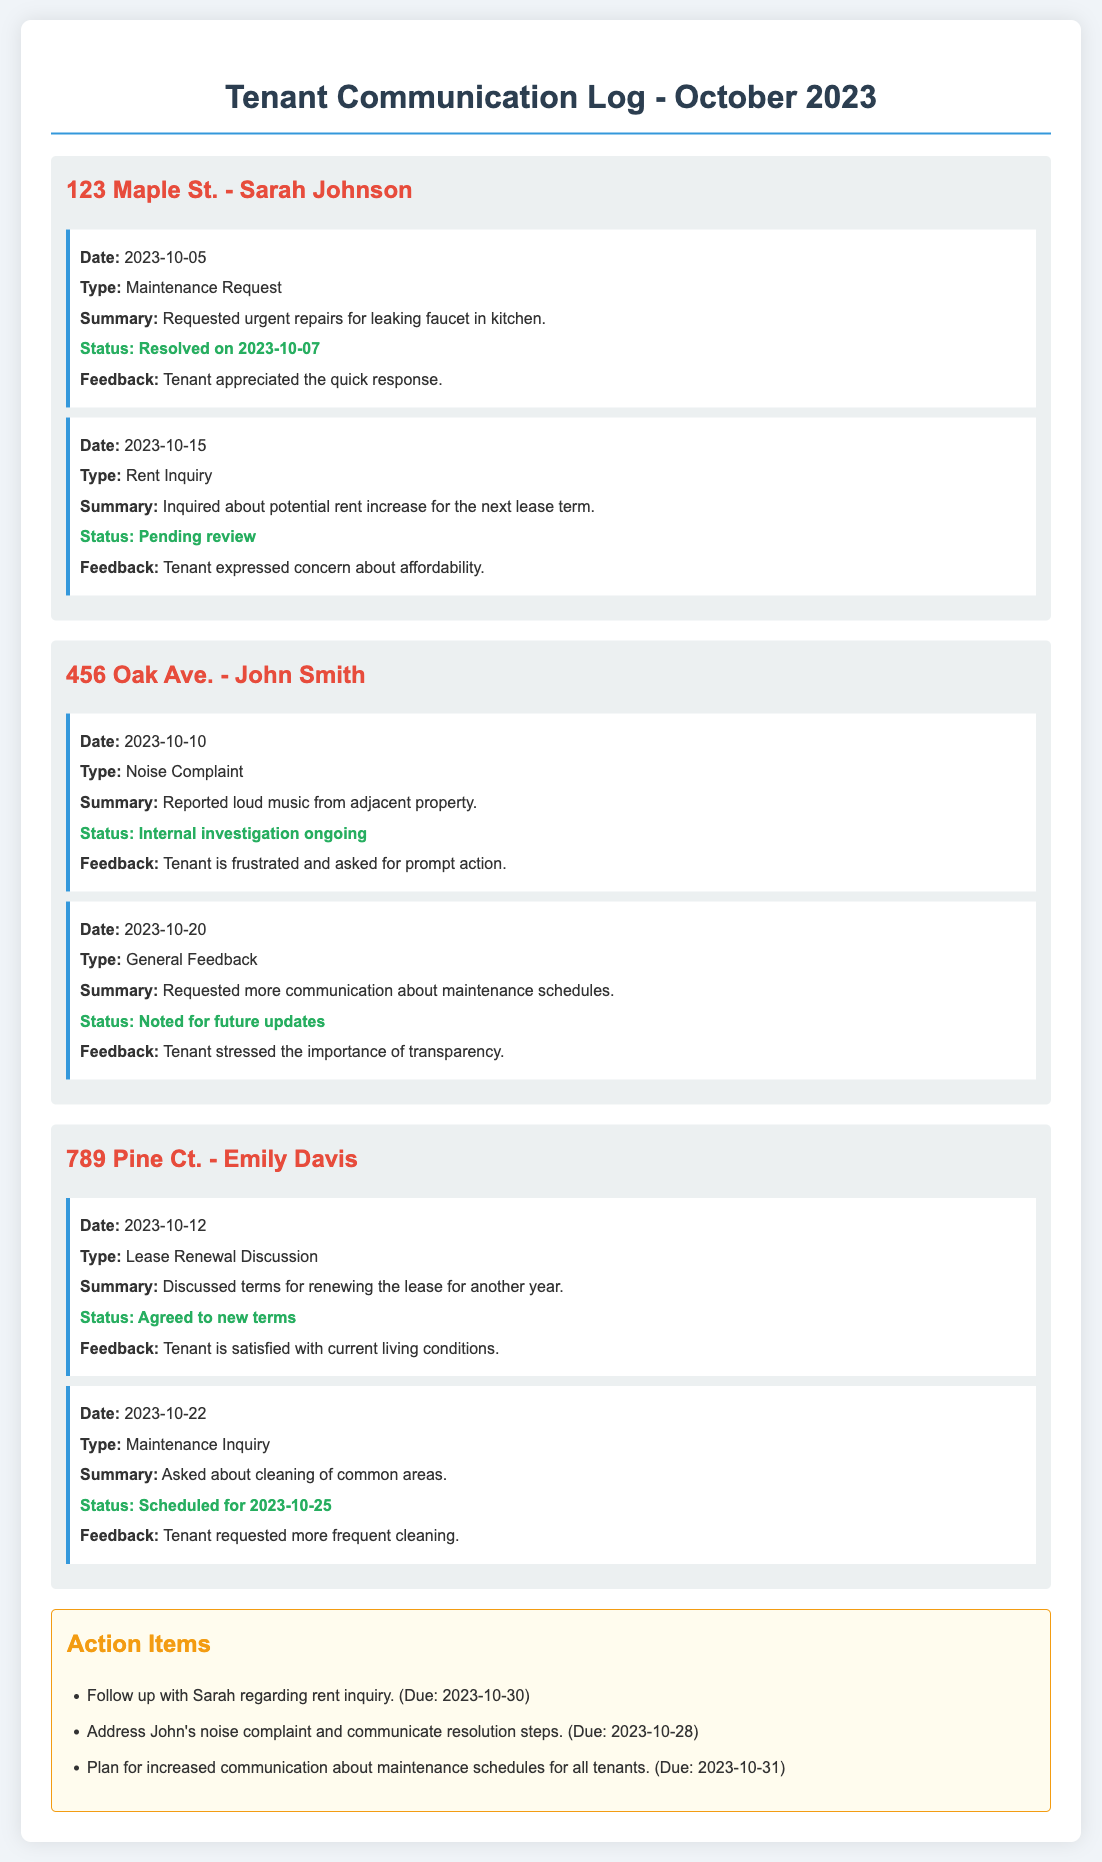what is the name of the tenant at 123 Maple St.? The name of the tenant at 123 Maple St. is Sarah Johnson.
Answer: Sarah Johnson what was the date of the maintenance request in October for 456 Oak Ave.? The maintenance request for 456 Oak Ave. was on October 10, 2023.
Answer: 2023-10-10 what issue did John Smith report? John Smith reported a noise complaint regarding loud music.
Answer: Noise Complaint how many tenants expressed concerns about communication? Two tenants expressed concerns about communication: John Smith and Sarah Johnson.
Answer: Two what is the status of the maintenance inquiry from Emily Davis? The maintenance inquiry from Emily Davis is scheduled for cleaning of common areas on 2023-10-25.
Answer: Scheduled for 2023-10-25 what feedback did Sarah Johnson provide following the maintenance request? Sarah Johnson appreciated the quick response to her maintenance request.
Answer: Appreciated the quick response what are the action items mentioned in the log? The action items include follow-ups regarding inquiries and communication improvements.
Answer: Follow-ups and communication improvements what was the outcome of the lease renewal discussion with Emily Davis? The outcome of the lease renewal discussion with Emily Davis was that she agreed to the new terms.
Answer: Agreed to new terms 